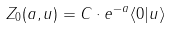Convert formula to latex. <formula><loc_0><loc_0><loc_500><loc_500>Z _ { 0 } ( a , u ) = C \cdot e ^ { - a } \langle 0 | u \rangle</formula> 